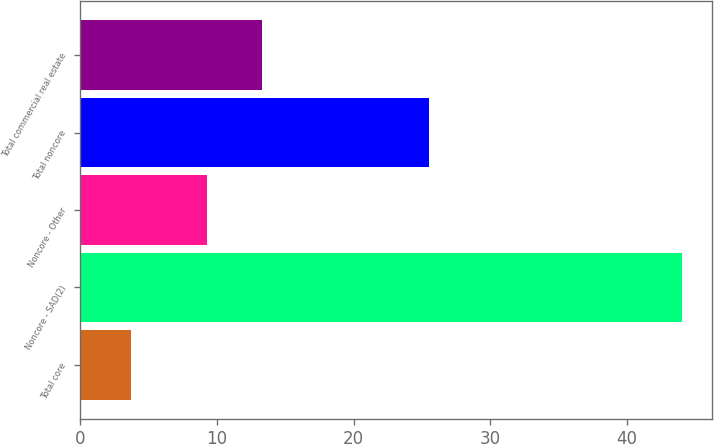<chart> <loc_0><loc_0><loc_500><loc_500><bar_chart><fcel>Total core<fcel>Noncore - SAD(2)<fcel>Noncore - Other<fcel>Total noncore<fcel>Total commercial real estate<nl><fcel>3.75<fcel>44.03<fcel>9.29<fcel>25.5<fcel>13.32<nl></chart> 